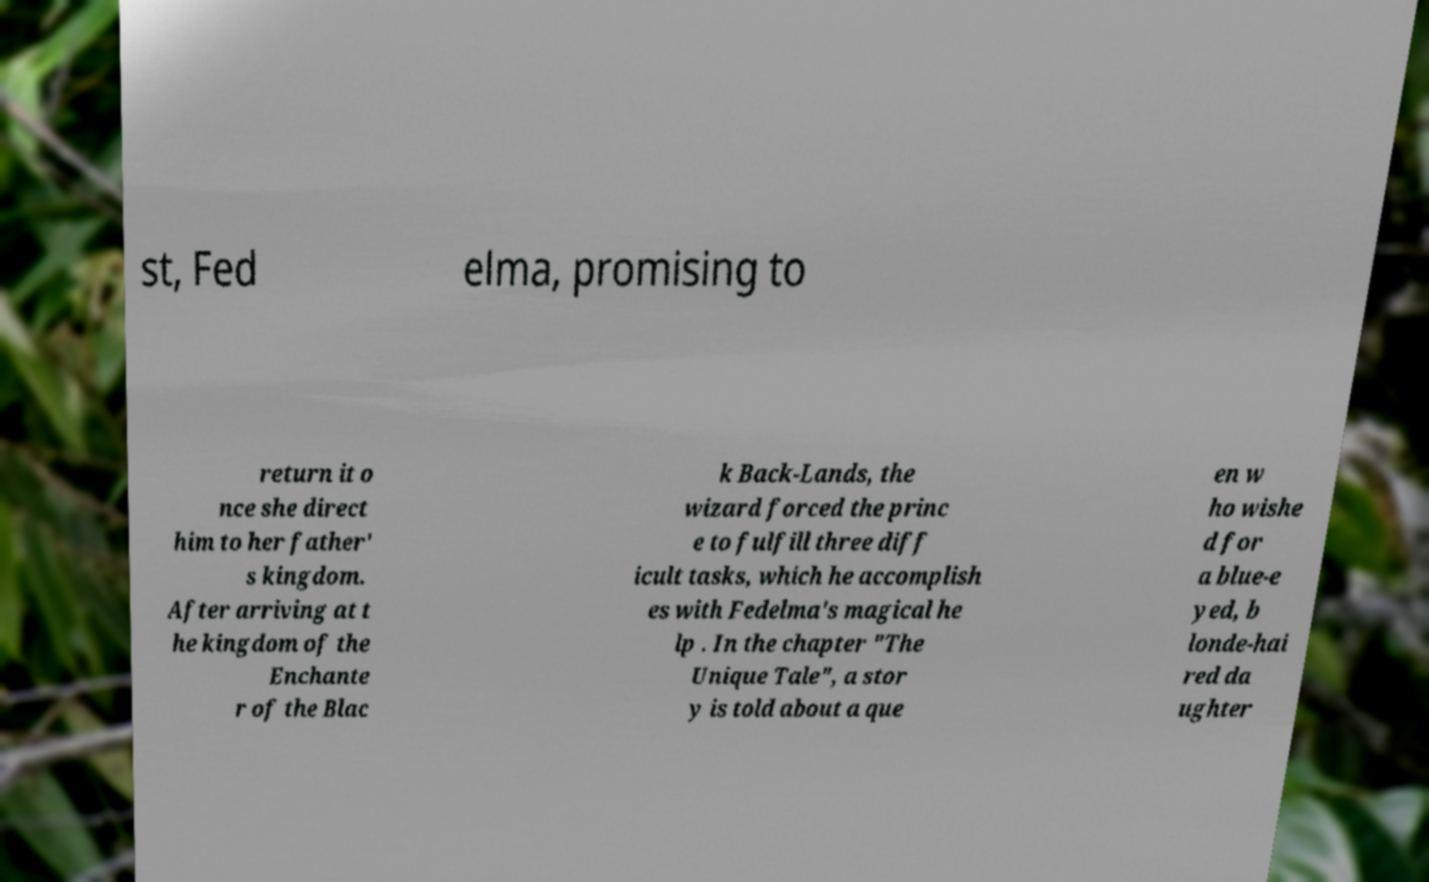Could you extract and type out the text from this image? st, Fed elma, promising to return it o nce she direct him to her father' s kingdom. After arriving at t he kingdom of the Enchante r of the Blac k Back-Lands, the wizard forced the princ e to fulfill three diff icult tasks, which he accomplish es with Fedelma's magical he lp . In the chapter "The Unique Tale", a stor y is told about a que en w ho wishe d for a blue-e yed, b londe-hai red da ughter 